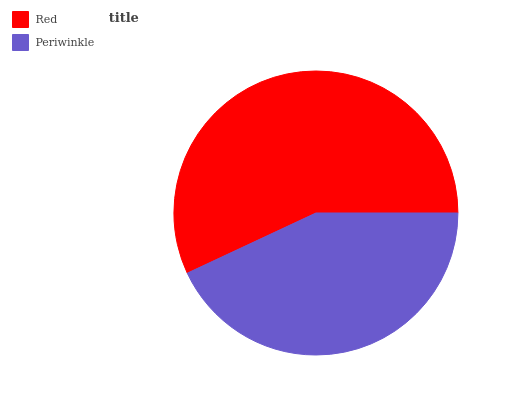Is Periwinkle the minimum?
Answer yes or no. Yes. Is Red the maximum?
Answer yes or no. Yes. Is Periwinkle the maximum?
Answer yes or no. No. Is Red greater than Periwinkle?
Answer yes or no. Yes. Is Periwinkle less than Red?
Answer yes or no. Yes. Is Periwinkle greater than Red?
Answer yes or no. No. Is Red less than Periwinkle?
Answer yes or no. No. Is Red the high median?
Answer yes or no. Yes. Is Periwinkle the low median?
Answer yes or no. Yes. Is Periwinkle the high median?
Answer yes or no. No. Is Red the low median?
Answer yes or no. No. 